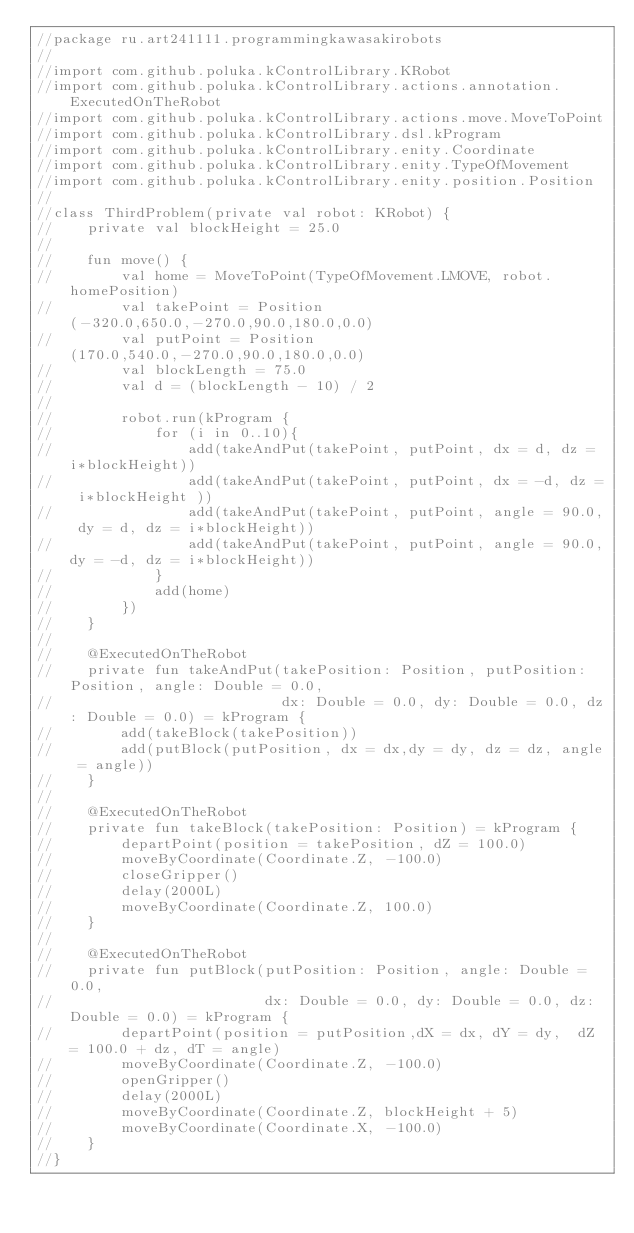<code> <loc_0><loc_0><loc_500><loc_500><_Kotlin_>//package ru.art241111.programmingkawasakirobots
//
//import com.github.poluka.kControlLibrary.KRobot
//import com.github.poluka.kControlLibrary.actions.annotation.ExecutedOnTheRobot
//import com.github.poluka.kControlLibrary.actions.move.MoveToPoint
//import com.github.poluka.kControlLibrary.dsl.kProgram
//import com.github.poluka.kControlLibrary.enity.Coordinate
//import com.github.poluka.kControlLibrary.enity.TypeOfMovement
//import com.github.poluka.kControlLibrary.enity.position.Position
//
//class ThirdProblem(private val robot: KRobot) {
//    private val blockHeight = 25.0
//
//    fun move() {
//        val home = MoveToPoint(TypeOfMovement.LMOVE, robot.homePosition)
//        val takePoint = Position(-320.0,650.0,-270.0,90.0,180.0,0.0)
//        val putPoint = Position(170.0,540.0,-270.0,90.0,180.0,0.0)
//        val blockLength = 75.0
//        val d = (blockLength - 10) / 2
//
//        robot.run(kProgram {
//            for (i in 0..10){
//                add(takeAndPut(takePoint, putPoint, dx = d, dz = i*blockHeight))
//                add(takeAndPut(takePoint, putPoint, dx = -d, dz = i*blockHeight ))
//                add(takeAndPut(takePoint, putPoint, angle = 90.0, dy = d, dz = i*blockHeight))
//                add(takeAndPut(takePoint, putPoint, angle = 90.0,dy = -d, dz = i*blockHeight))
//            }
//            add(home)
//        })
//    }
//
//    @ExecutedOnTheRobot
//    private fun takeAndPut(takePosition: Position, putPosition: Position, angle: Double = 0.0,
//                           dx: Double = 0.0, dy: Double = 0.0, dz: Double = 0.0) = kProgram {
//        add(takeBlock(takePosition))
//        add(putBlock(putPosition, dx = dx,dy = dy, dz = dz, angle = angle))
//    }
//
//    @ExecutedOnTheRobot
//    private fun takeBlock(takePosition: Position) = kProgram {
//        departPoint(position = takePosition, dZ = 100.0)
//        moveByCoordinate(Coordinate.Z, -100.0)
//        closeGripper()
//        delay(2000L)
//        moveByCoordinate(Coordinate.Z, 100.0)
//    }
//
//    @ExecutedOnTheRobot
//    private fun putBlock(putPosition: Position, angle: Double = 0.0,
//                         dx: Double = 0.0, dy: Double = 0.0, dz: Double = 0.0) = kProgram {
//        departPoint(position = putPosition,dX = dx, dY = dy,  dZ = 100.0 + dz, dT = angle)
//        moveByCoordinate(Coordinate.Z, -100.0)
//        openGripper()
//        delay(2000L)
//        moveByCoordinate(Coordinate.Z, blockHeight + 5)
//        moveByCoordinate(Coordinate.X, -100.0)
//    }
//}</code> 